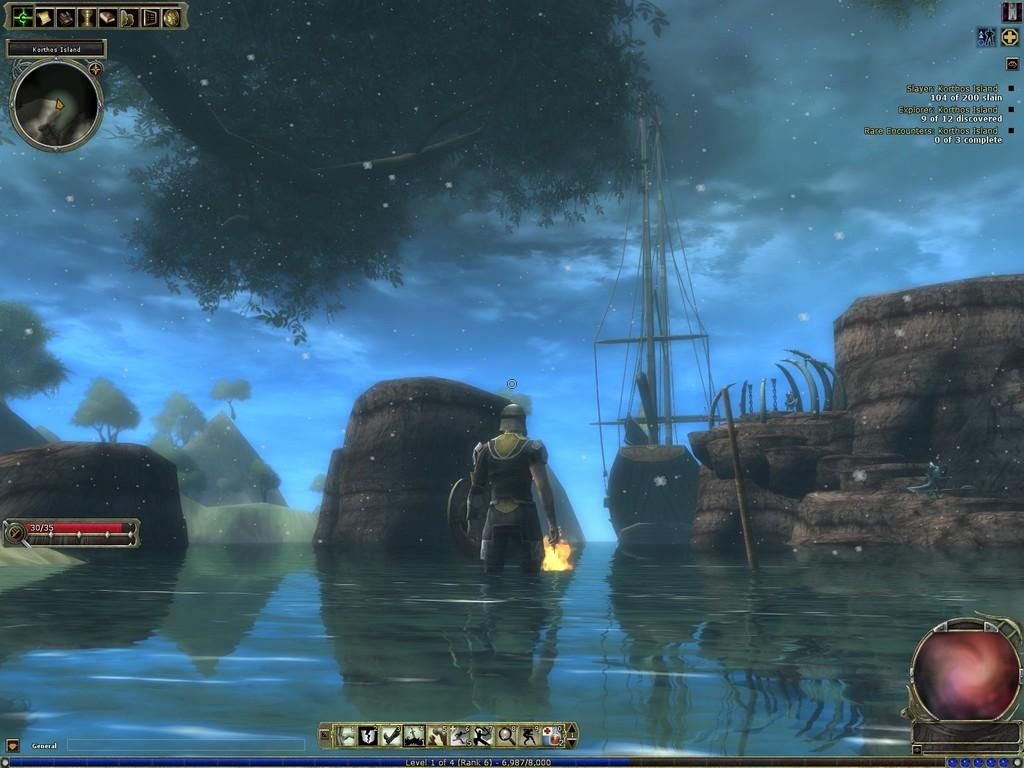What type of picture is the image? The image is an animated picture. Can you describe the person in the image? There is a person standing in the image. What type of natural environment is present in the image? There are trees in the image. What object can be seen in the person's hand? There is a stick in the image. What structures are present in the image with strings attached? There are poles with strings in the image. What part of the natural environment is visible in the image? The sky is visible in the image. What type of veil is draped over the person's head in the image? There is no veil present in the image; the person is not wearing any head covering. How can the person measure the distance between the poles in the image? The image does not show any measuring tools or actions related to measuring distances. 